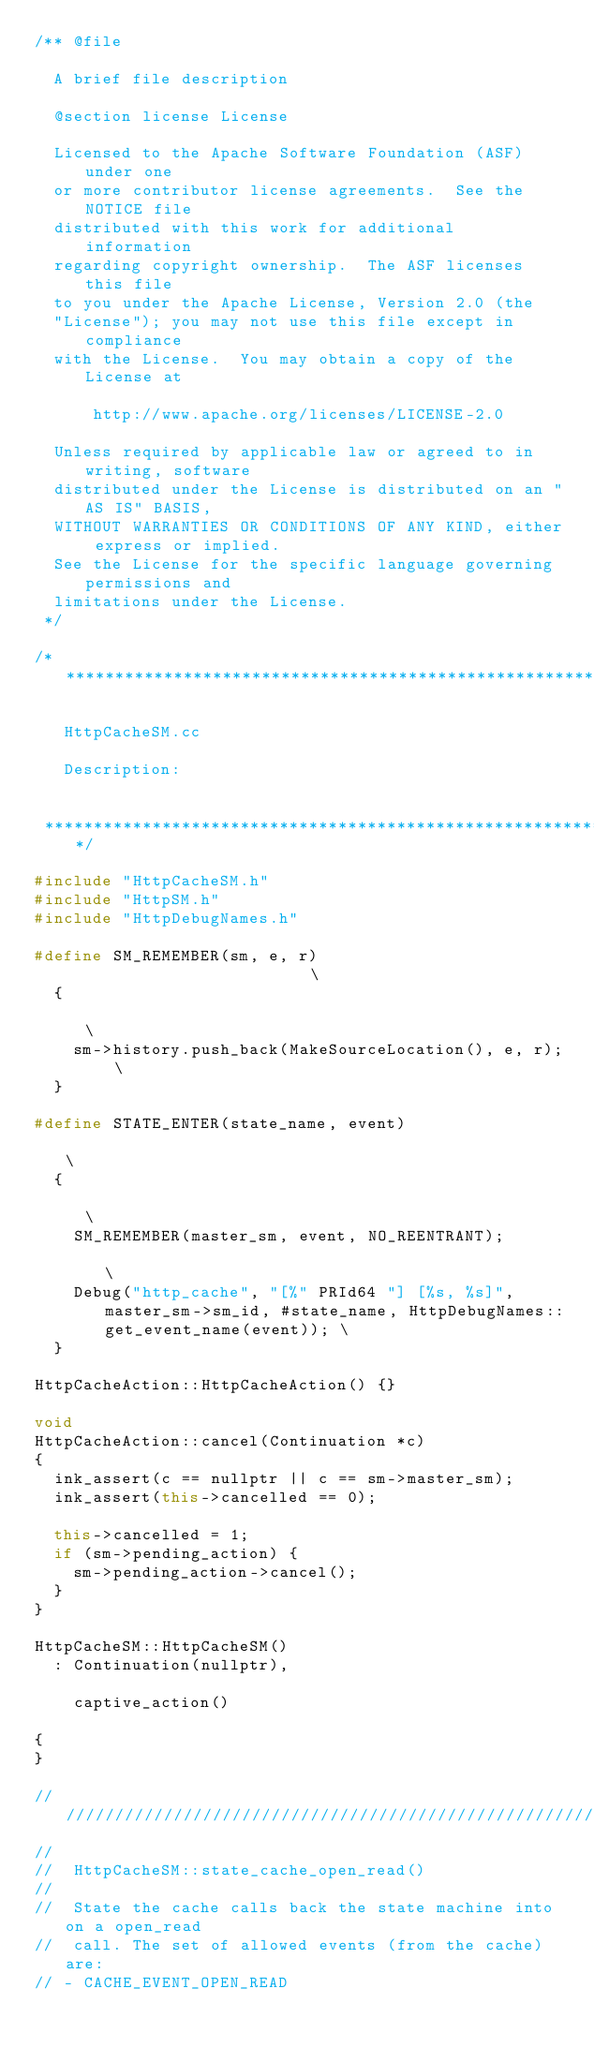Convert code to text. <code><loc_0><loc_0><loc_500><loc_500><_C++_>/** @file

  A brief file description

  @section license License

  Licensed to the Apache Software Foundation (ASF) under one
  or more contributor license agreements.  See the NOTICE file
  distributed with this work for additional information
  regarding copyright ownership.  The ASF licenses this file
  to you under the Apache License, Version 2.0 (the
  "License"); you may not use this file except in compliance
  with the License.  You may obtain a copy of the License at

      http://www.apache.org/licenses/LICENSE-2.0

  Unless required by applicable law or agreed to in writing, software
  distributed under the License is distributed on an "AS IS" BASIS,
  WITHOUT WARRANTIES OR CONDITIONS OF ANY KIND, either express or implied.
  See the License for the specific language governing permissions and
  limitations under the License.
 */

/****************************************************************************

   HttpCacheSM.cc

   Description:


 ****************************************************************************/

#include "HttpCacheSM.h"
#include "HttpSM.h"
#include "HttpDebugNames.h"

#define SM_REMEMBER(sm, e, r)                          \
  {                                                    \
    sm->history.push_back(MakeSourceLocation(), e, r); \
  }

#define STATE_ENTER(state_name, event)                                                                                   \
  {                                                                                                                      \
    SM_REMEMBER(master_sm, event, NO_REENTRANT);                                                                         \
    Debug("http_cache", "[%" PRId64 "] [%s, %s]", master_sm->sm_id, #state_name, HttpDebugNames::get_event_name(event)); \
  }

HttpCacheAction::HttpCacheAction() {}

void
HttpCacheAction::cancel(Continuation *c)
{
  ink_assert(c == nullptr || c == sm->master_sm);
  ink_assert(this->cancelled == 0);

  this->cancelled = 1;
  if (sm->pending_action) {
    sm->pending_action->cancel();
  }
}

HttpCacheSM::HttpCacheSM()
  : Continuation(nullptr),

    captive_action()

{
}

//////////////////////////////////////////////////////////////////////////
//
//  HttpCacheSM::state_cache_open_read()
//
//  State the cache calls back the state machine into on a open_read
//  call. The set of allowed events (from the cache) are:
// - CACHE_EVENT_OPEN_READ</code> 